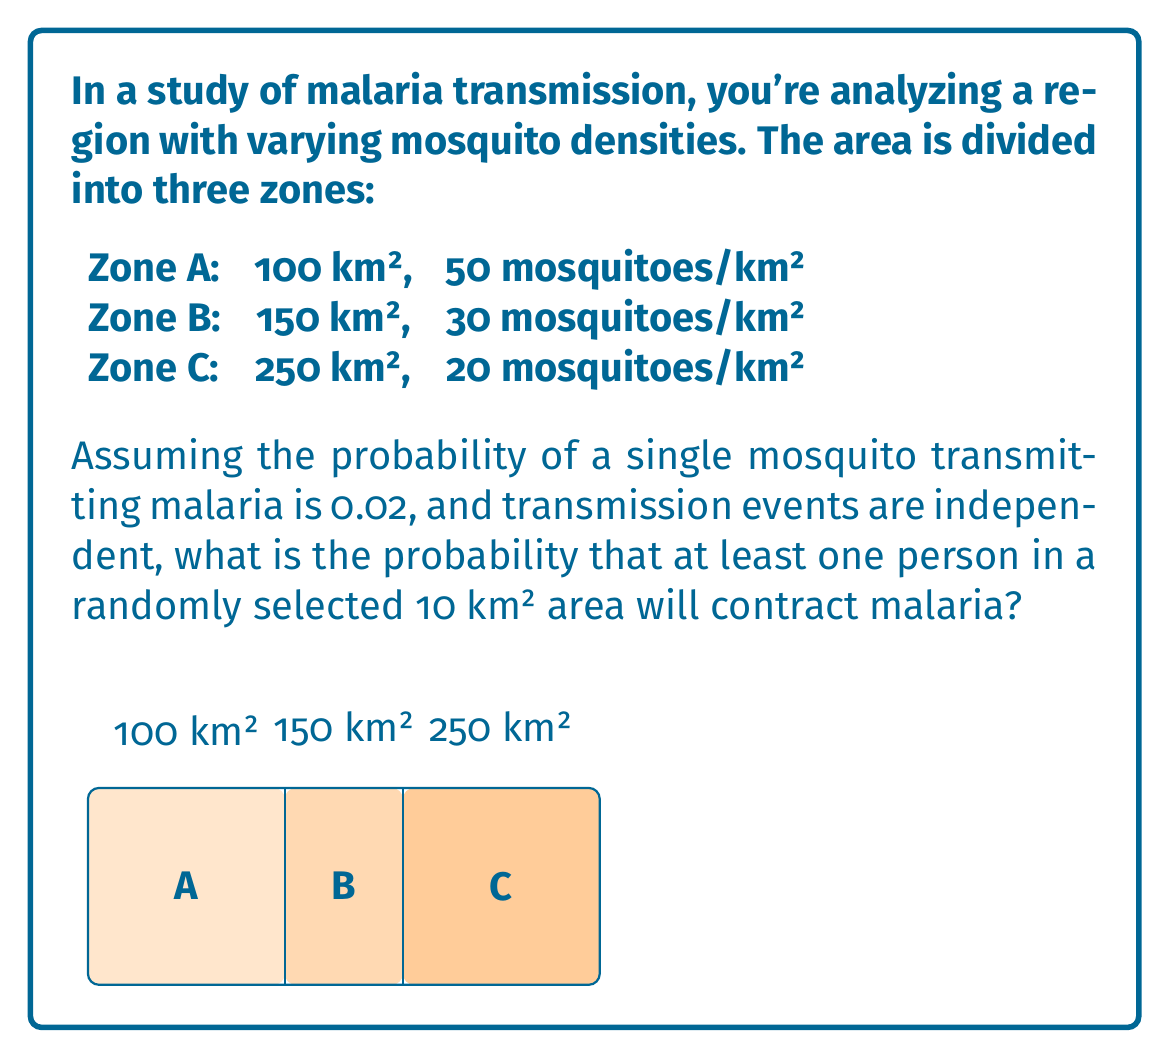Give your solution to this math problem. Let's approach this step-by-step:

1) First, we need to calculate the average mosquito density for the entire region:

   Total area = 100 + 150 + 250 = 500 km²
   Total mosquitoes = (100 * 50) + (150 * 30) + (250 * 20) = 14,000
   Average density = 14,000 / 500 = 28 mosquitoes/km²

2) In a randomly selected 10 km² area, we expect:
   
   28 * 10 = 280 mosquitoes

3) The probability of at least one person contracting malaria is the complement of the probability of no one contracting malaria:

   $P(\text{at least one}) = 1 - P(\text{none})$

4) The probability of a single mosquito not transmitting malaria is:

   $1 - 0.02 = 0.98$

5) For no one to contract malaria, all 280 mosquitoes must not transmit the disease:

   $P(\text{none}) = 0.98^{280}$

6) Therefore, the probability of at least one person contracting malaria is:

   $P(\text{at least one}) = 1 - 0.98^{280}$

7) Calculating this:

   $1 - 0.98^{280} \approx 0.9962$

Thus, there's approximately a 99.62% chance that at least one person in a randomly selected 10 km² area will contract malaria.
Answer: $1 - 0.98^{280} \approx 0.9962$ or 99.62% 